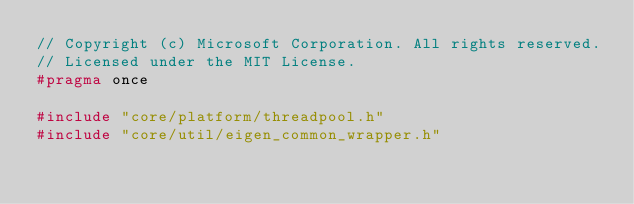<code> <loc_0><loc_0><loc_500><loc_500><_C_>// Copyright (c) Microsoft Corporation. All rights reserved.
// Licensed under the MIT License.
#pragma once

#include "core/platform/threadpool.h"
#include "core/util/eigen_common_wrapper.h"</code> 